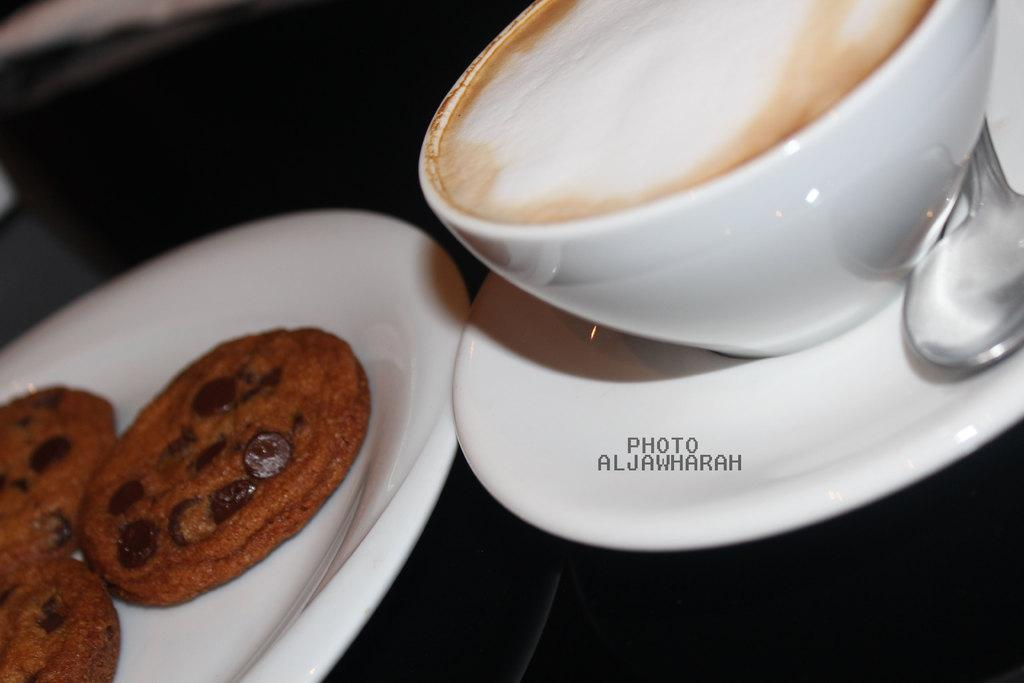What type of food can be seen on a plate in the image? There are cookies on a plate in the image. What is the cup used for in the image? The cup is likely used for holding a beverage, but its contents are not visible in the image. What is the saucer used for in the image? The saucer is likely used to hold the cup or to catch any spills, but its specific purpose is not clear from the image. What utensil is present in the image? There is a spoon in the image. How far away is the badge from the cookies in the image? There is no badge present in the image, so it cannot be determined how far away it would be from the cookies. 